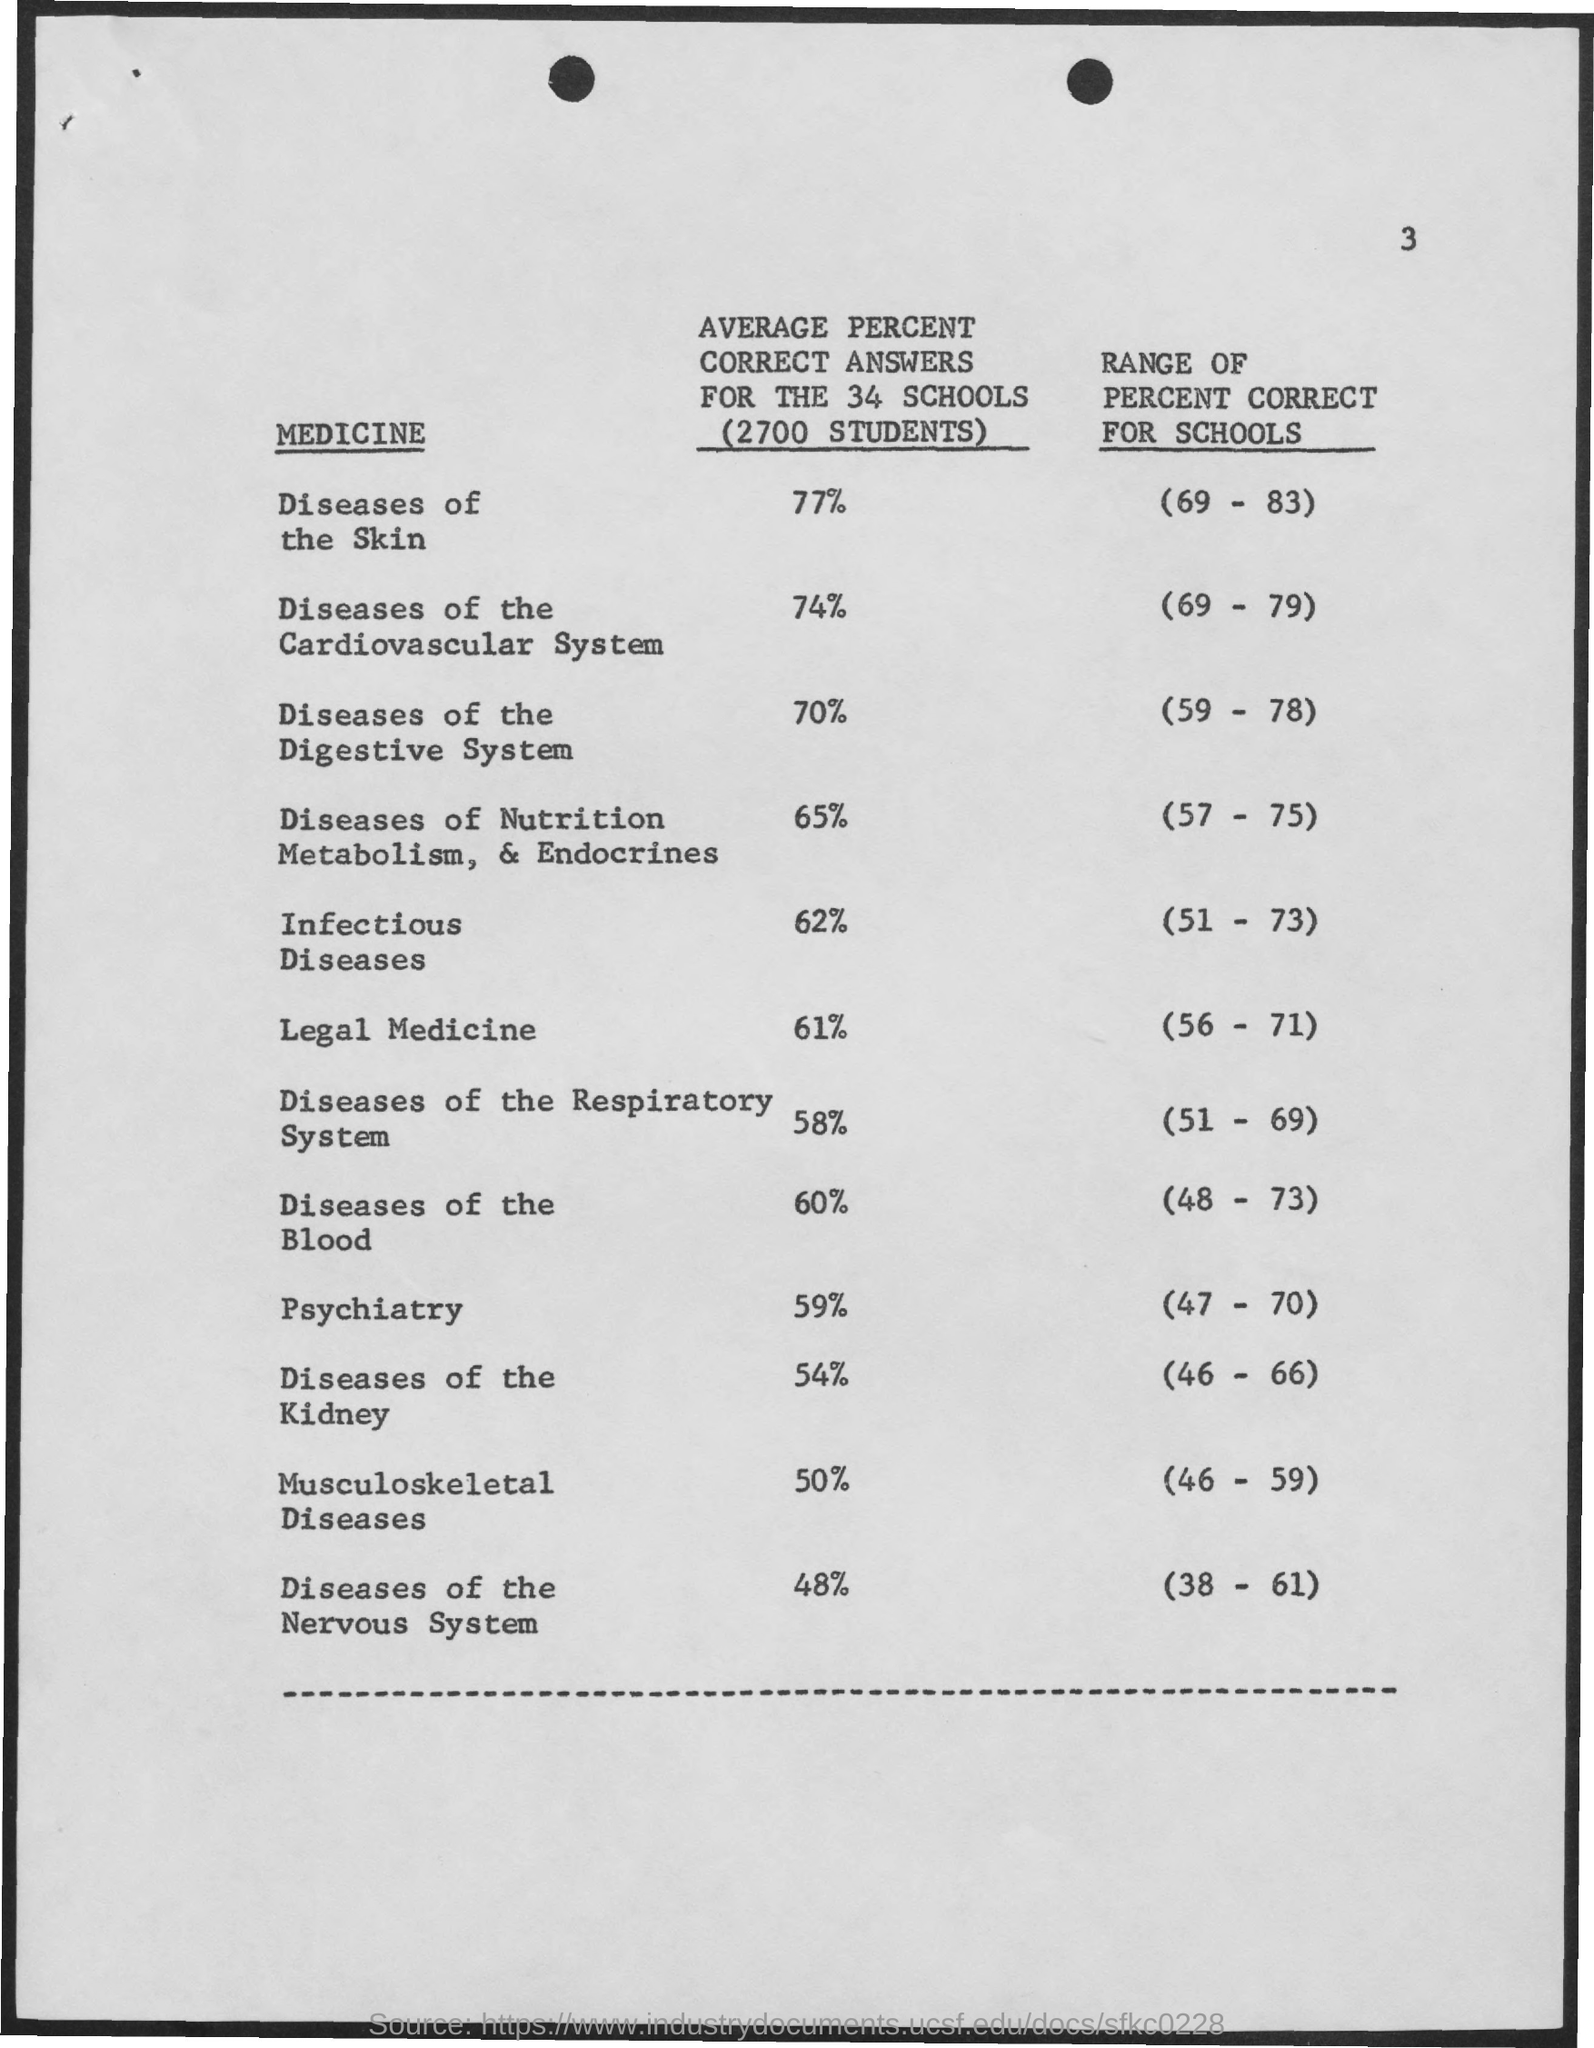Outline some significant characteristics in this image. There are 34 schools. The number of students is approximately 2700. 